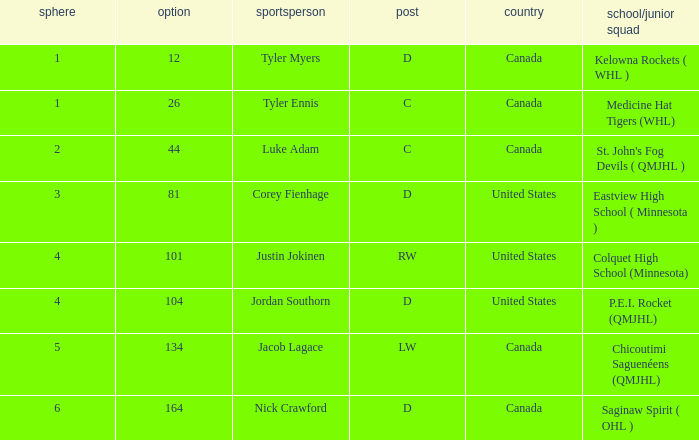What is the sum of the pick of the lw position player? 134.0. 